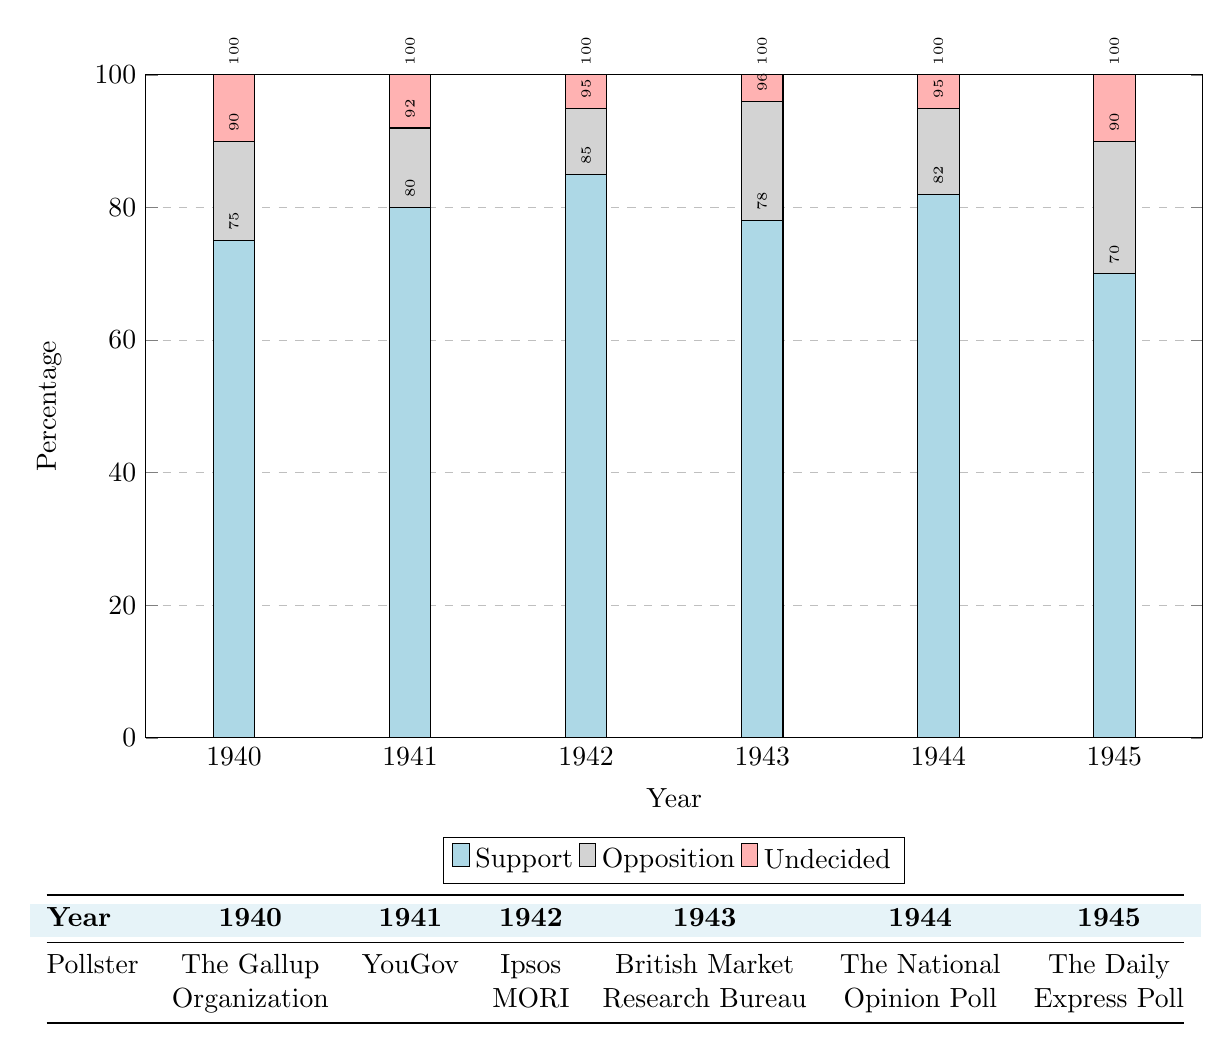What was the support percentage for Churchill in 1942? According to the table, the support percentage for Churchill in 1942 is listed under the "Support" category for that year, which shows 85%.
Answer: 85% Which pollster reported the highest support for Churchill, and what was that percentage? From the table, Ipsos MORI in 1942 reported the highest support percentage at 85%.
Answer: Ipsos MORI, 85% What were the undecided percentages for Churchill's leadership in 1943 and 1944? In the table, the undecided percentages are shown as 4% for 1943 and 5% for 1944.
Answer: 4%, 5% What is the average support percentage for Churchill over the years listed in the table? To calculate the average, we sum the support percentages: 75 + 80 + 85 + 78 + 82 + 70 = 470. Then we divide by the number of years, which is 6. So, 470 / 6 = 78.33.
Answer: 78.33 Did the support for Churchill decrease in 1945 compared to 1944? In the table, the support percentage for 1945 is 70%, while it is 82% for 1944. Since 70% is less than 82%, it is true that support decreased.
Answer: Yes What was the opposition percentage in 1941 and how does it compare to the opposition percentage in 1945? The opposition percentage in 1941 is 12%, and in 1945 it is 20%. Comparing these two, 20% in 1945 is higher than 12% in 1941.
Answer: 12%, 20%, 20% is higher Calculate the difference in undecided percentages between 1940 and 1943. The undecided percentage for 1940 is 10%, and for 1943 it is 4%. To find the difference, we subtract: 10% - 4% = 6%.
Answer: 6% Was there a year when the opposition percentage was below 10%? Looking at the table, the lowest opposition percentage recorded is 10% in 1942. Thus, there was no year when it was below 10%.
Answer: No In which year was the support percentage lowest and what was that percentage? By checking the support percentages for all years, the lowest was in 1945 at 70%.
Answer: 1945, 70% 